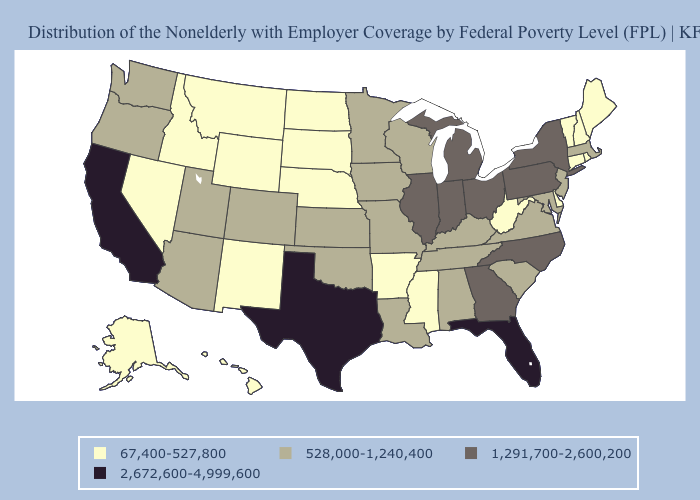Does Wyoming have a lower value than Vermont?
Keep it brief. No. Among the states that border Kentucky , does Illinois have the highest value?
Answer briefly. Yes. What is the value of Kansas?
Be succinct. 528,000-1,240,400. Does New Mexico have a lower value than Maryland?
Write a very short answer. Yes. What is the value of Alabama?
Give a very brief answer. 528,000-1,240,400. What is the value of North Dakota?
Keep it brief. 67,400-527,800. Is the legend a continuous bar?
Keep it brief. No. Name the states that have a value in the range 528,000-1,240,400?
Concise answer only. Alabama, Arizona, Colorado, Iowa, Kansas, Kentucky, Louisiana, Maryland, Massachusetts, Minnesota, Missouri, New Jersey, Oklahoma, Oregon, South Carolina, Tennessee, Utah, Virginia, Washington, Wisconsin. Name the states that have a value in the range 1,291,700-2,600,200?
Be succinct. Georgia, Illinois, Indiana, Michigan, New York, North Carolina, Ohio, Pennsylvania. What is the value of Wyoming?
Be succinct. 67,400-527,800. What is the value of Wyoming?
Quick response, please. 67,400-527,800. Among the states that border Michigan , does Ohio have the lowest value?
Be succinct. No. Does the map have missing data?
Keep it brief. No. What is the value of Hawaii?
Short answer required. 67,400-527,800. Among the states that border Rhode Island , does Massachusetts have the lowest value?
Write a very short answer. No. 